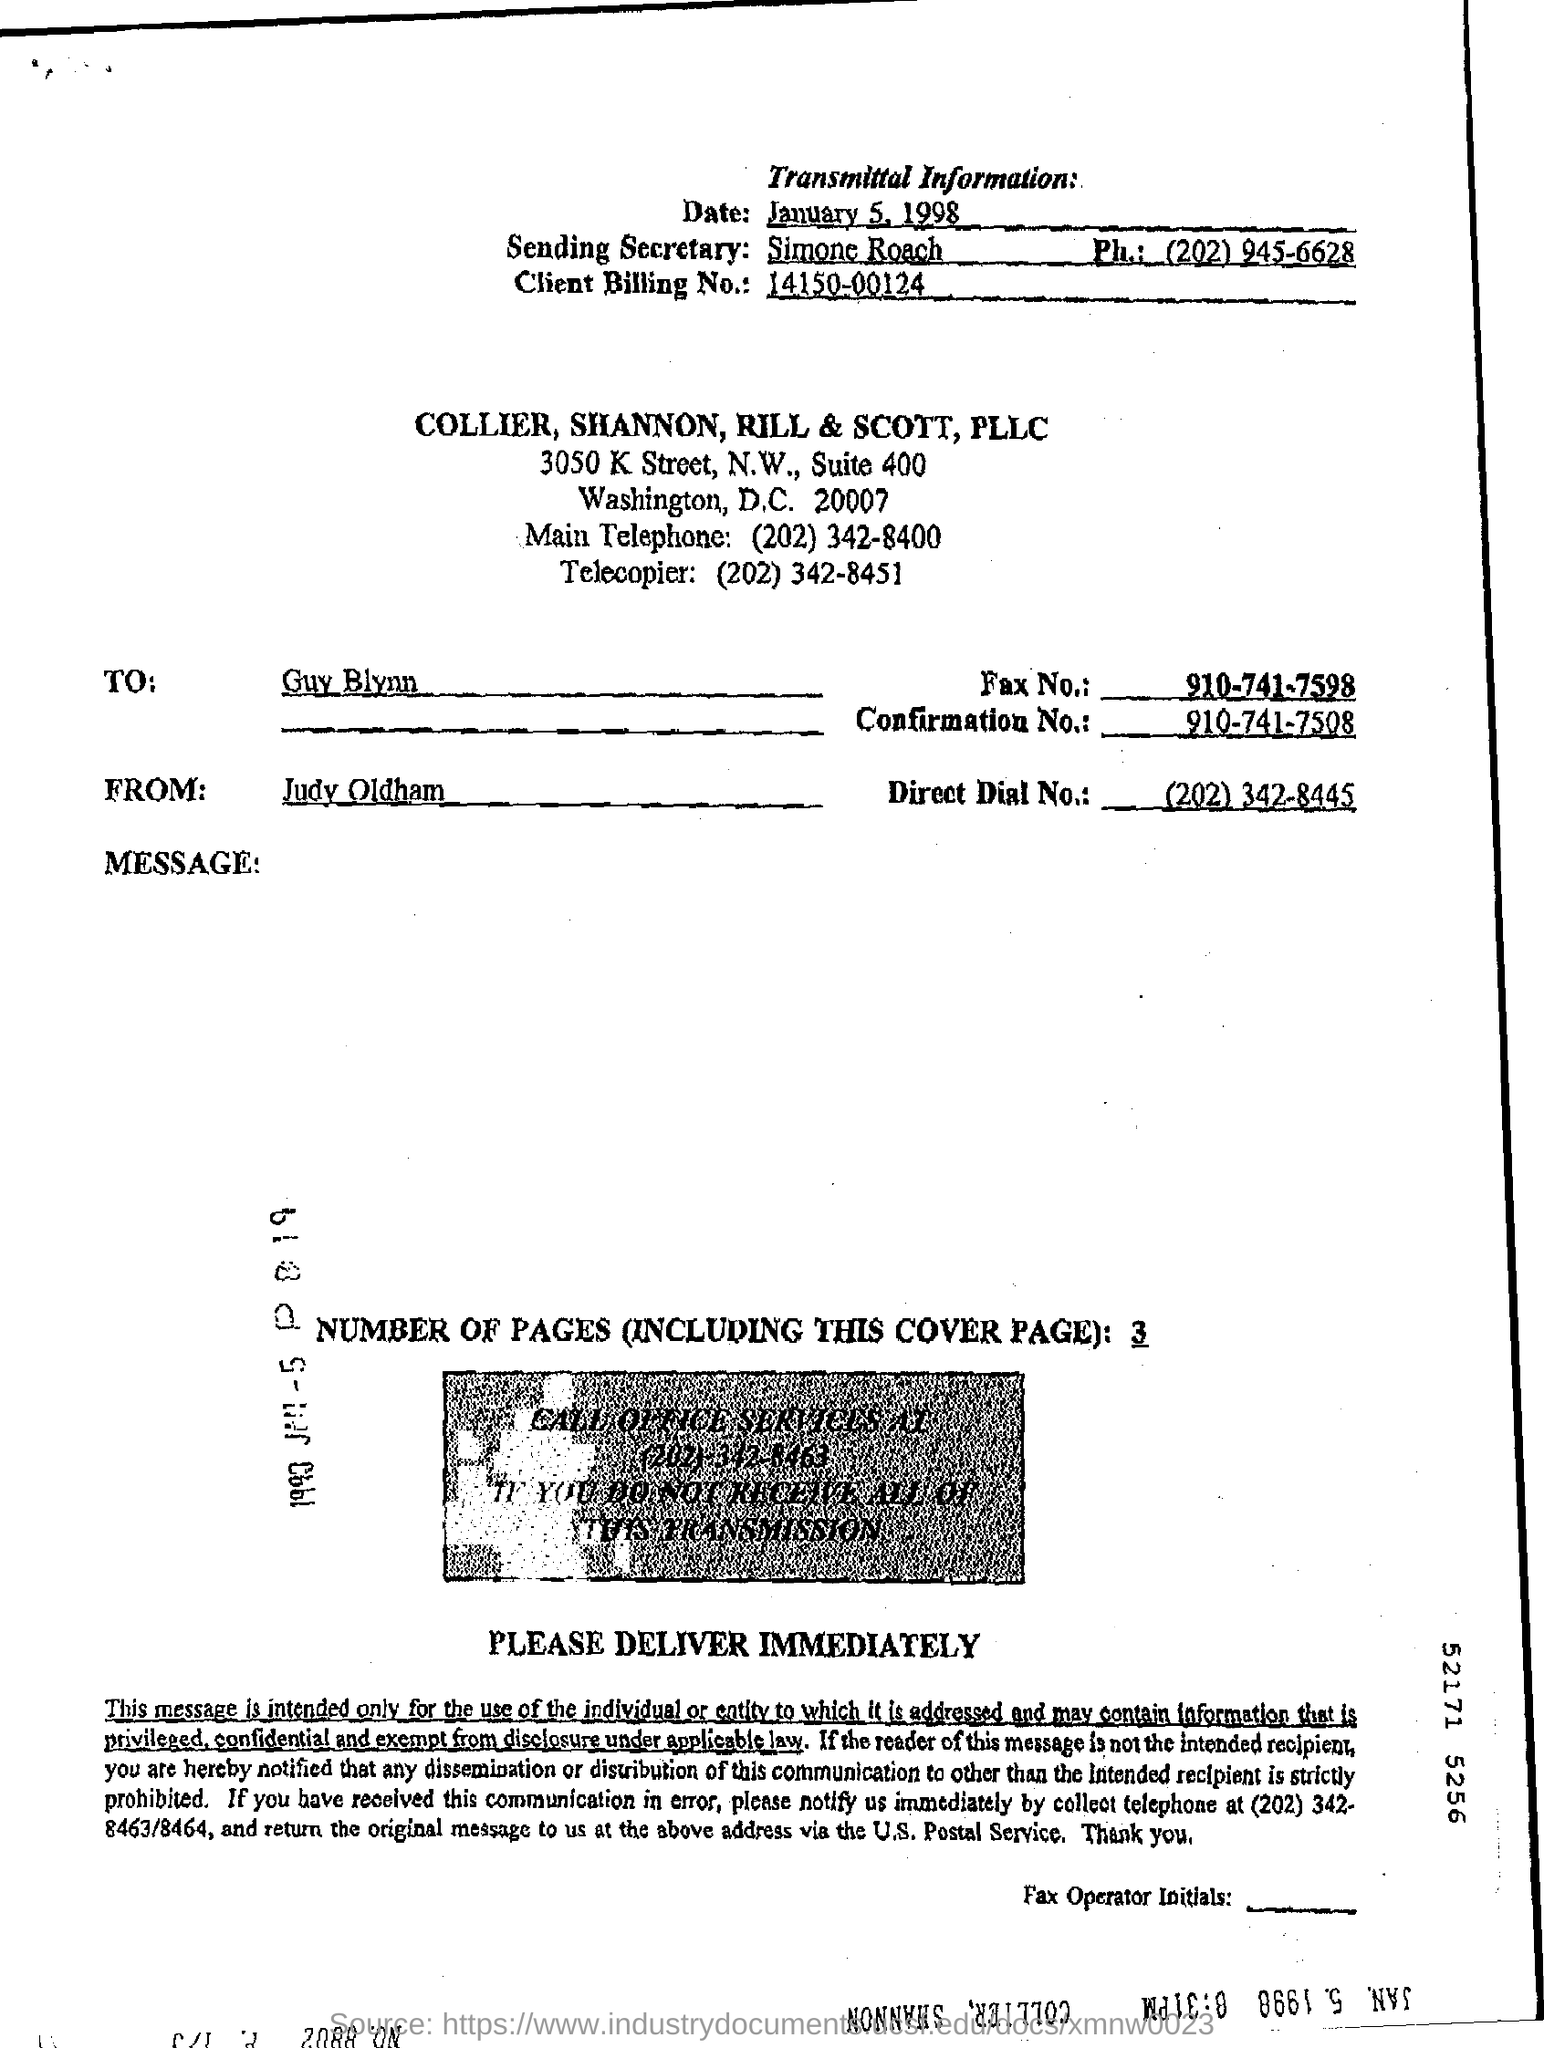What is the Client Billing No mentioned in the Fax transmittal?
Ensure brevity in your answer.  14150-00124. Who is the Sending Secretary?
Provide a succinct answer. Simone roach. Who is the sender of the Fax?
Offer a terse response. Judy oldham. Who is the receiver of the Fax?
Your answer should be very brief. Guy Blynn. What is the Confirmation No. given in the transmittal?
Make the answer very short. 910-741-7508. What is the Direct Dial No of Judy Oldham?
Your answer should be very brief. (202) 342-8445. How many pages are there in the fax including cover page?
Give a very brief answer. 3. What is the Fax No of Guy Blynn?
Offer a terse response. 910-741-7598. 